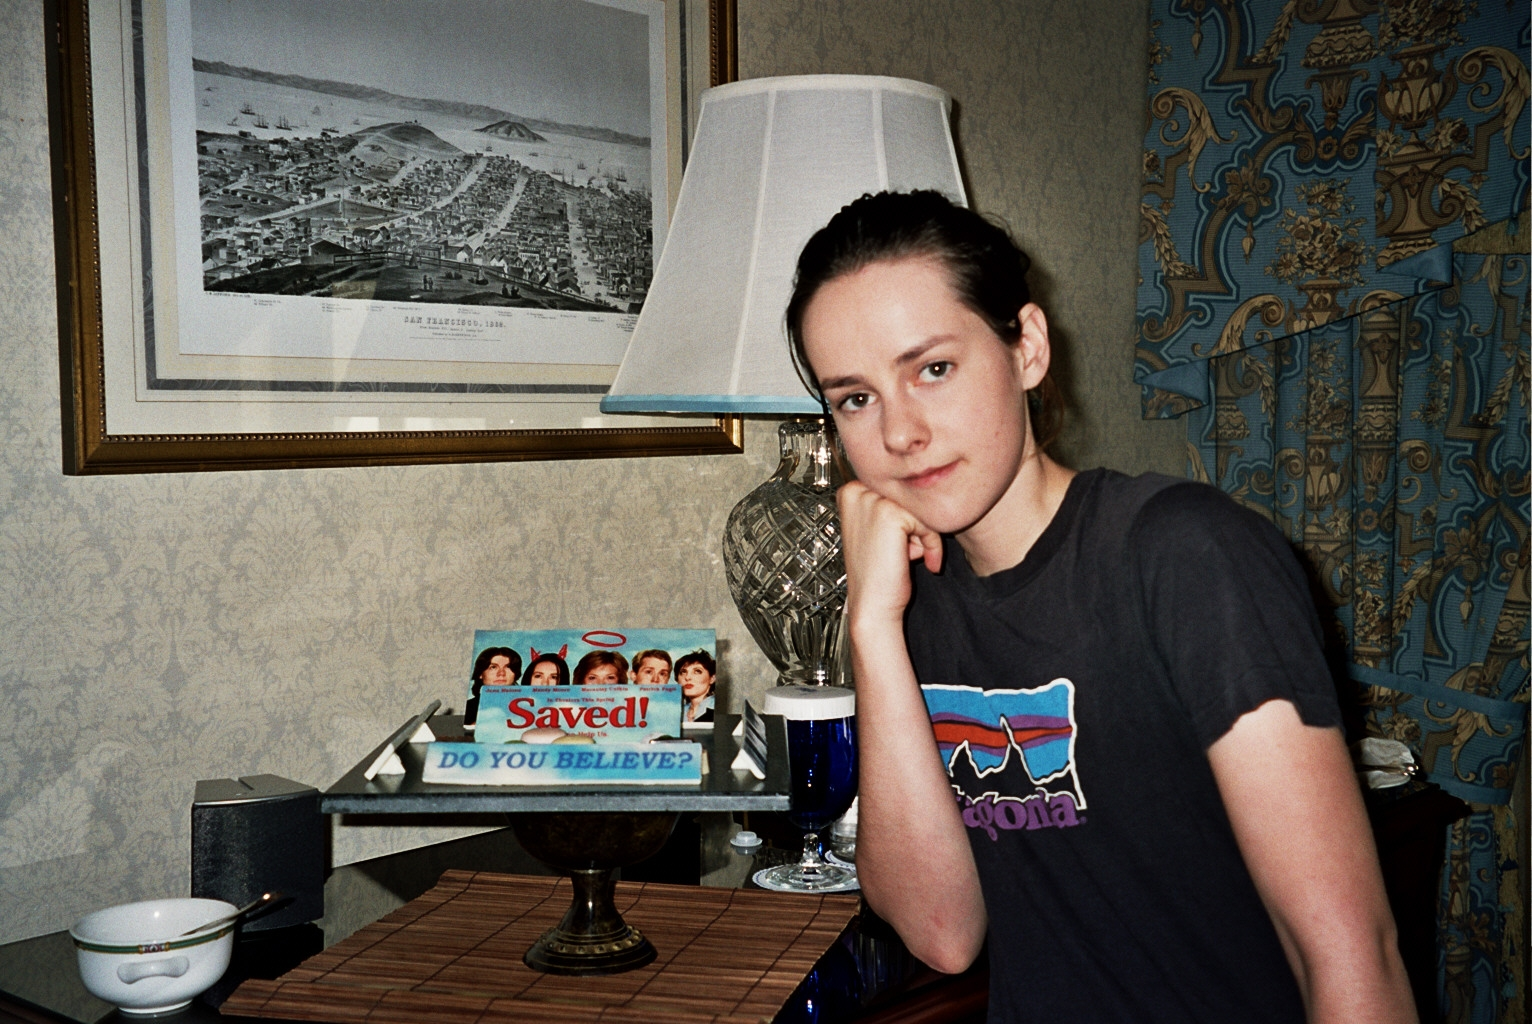Imagine this room existed in a different era. Describe what it might look like and who might inhabit it. If this room existed in the Victorian era, the walls might be adorned with elaborate floral wallpaper and heavy drapes in deep, rich colors like burgundy or forest green. The table would likely be a polished mahogany piece, holding a silver tea set instead of the modern-day teacup. Instead of a photograph of San Francisco, a hand-painted oil portrait might grace the wall. The inhabitant could be a scholarly individual, perhaps a writer or a historian, dressed in period attire, sitting by the table with a quill and parchment, immersed in thought or penning their next great work. 